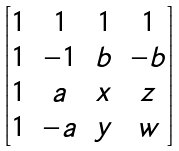Convert formula to latex. <formula><loc_0><loc_0><loc_500><loc_500>\begin{bmatrix} 1 & 1 & 1 & 1 \\ 1 & - 1 & b & - b \\ 1 & a & x & z \\ 1 & - a & y & w \end{bmatrix}</formula> 